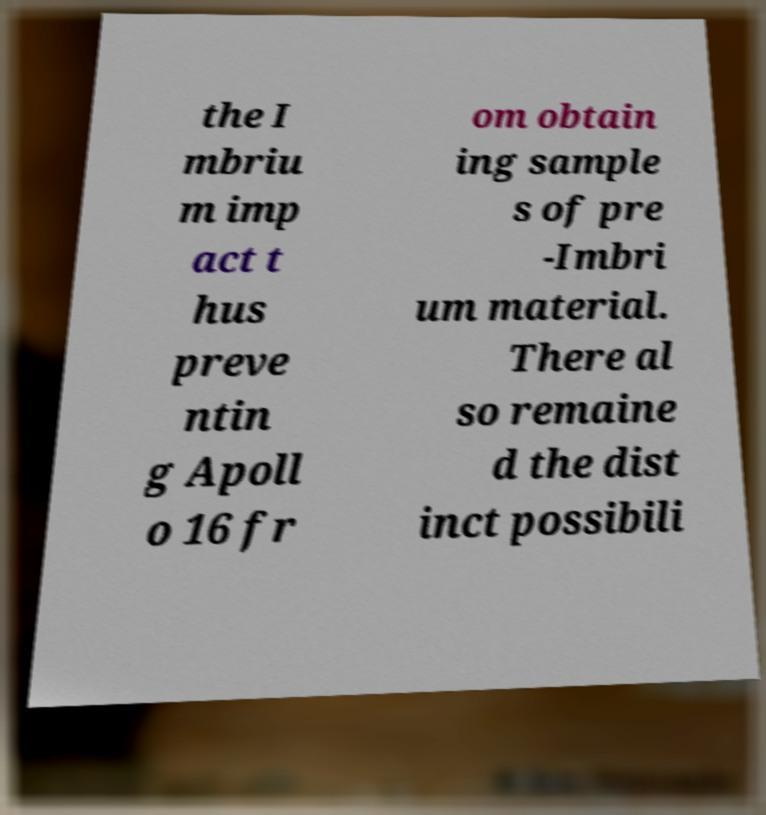Can you accurately transcribe the text from the provided image for me? the I mbriu m imp act t hus preve ntin g Apoll o 16 fr om obtain ing sample s of pre -Imbri um material. There al so remaine d the dist inct possibili 